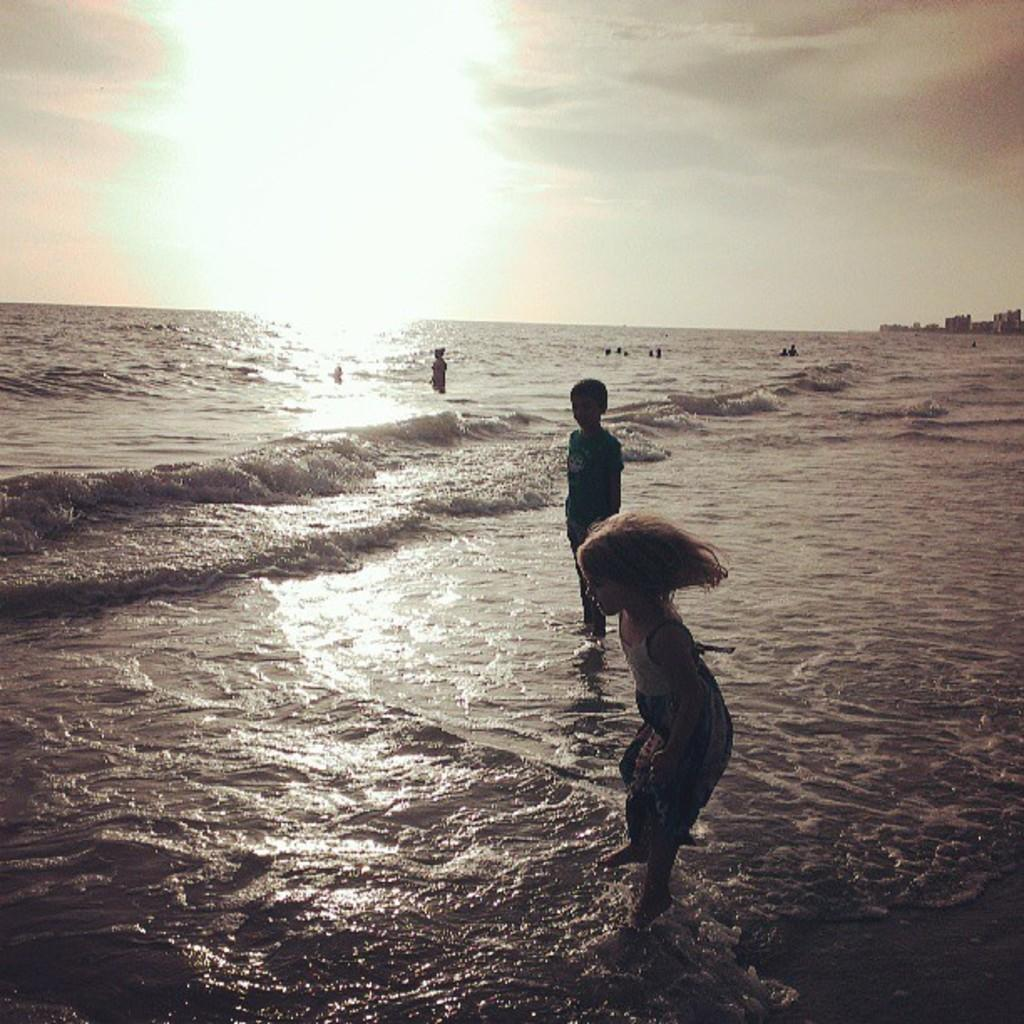What is present in the image that is related to a natural resource? There is water in the image. What can be seen near the water? There are people near the water. What part of the environment is visible in the image? The sky is visible in the image. What is located on the right side of the image? There are objects on the right side of the image. How many clocks are visible in the image? There are no clocks present in the image. What type of street is shown in the image? There is no street present in the image. 